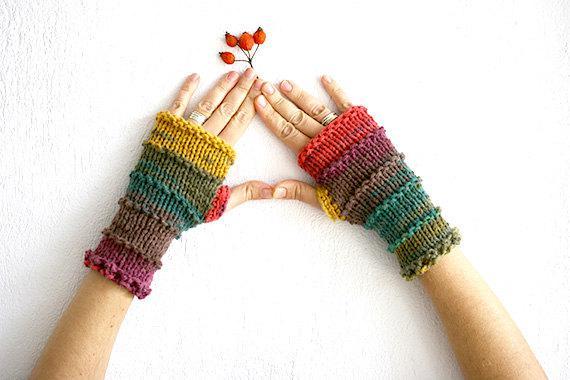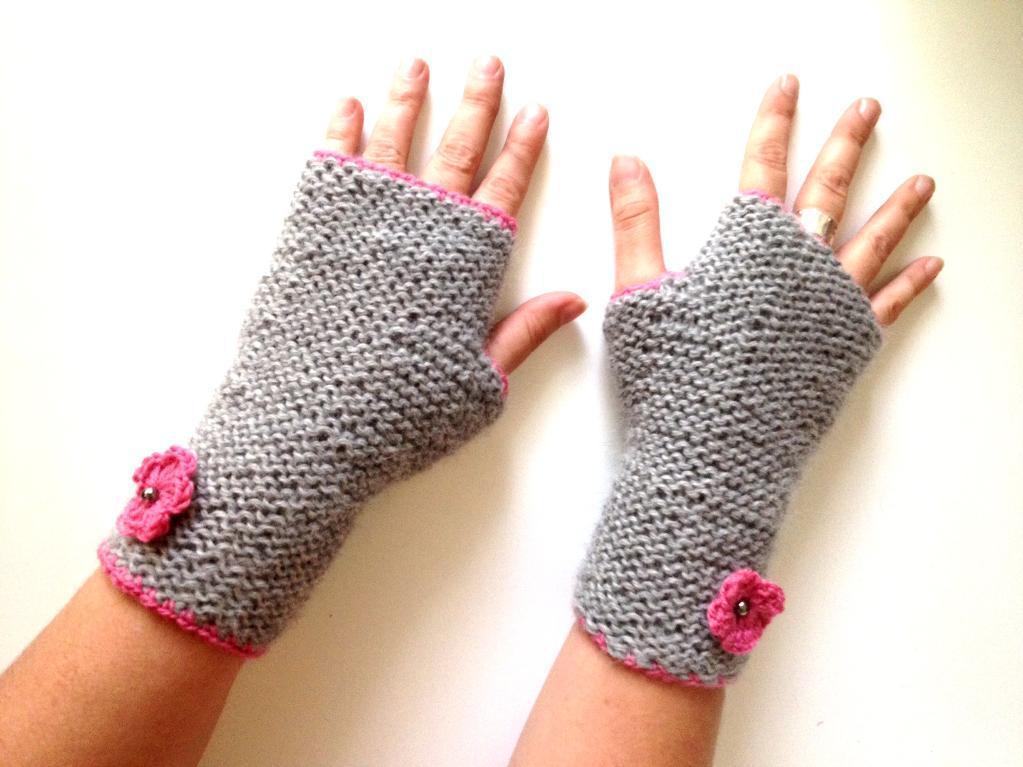The first image is the image on the left, the second image is the image on the right. For the images shown, is this caption "At least one mitten is being worn and at least one mitten is not." true? Answer yes or no. No. The first image is the image on the left, the second image is the image on the right. Analyze the images presented: Is the assertion "And at least one image there is somebody wearing mittens where the Fingers are not visible" valid? Answer yes or no. No. 